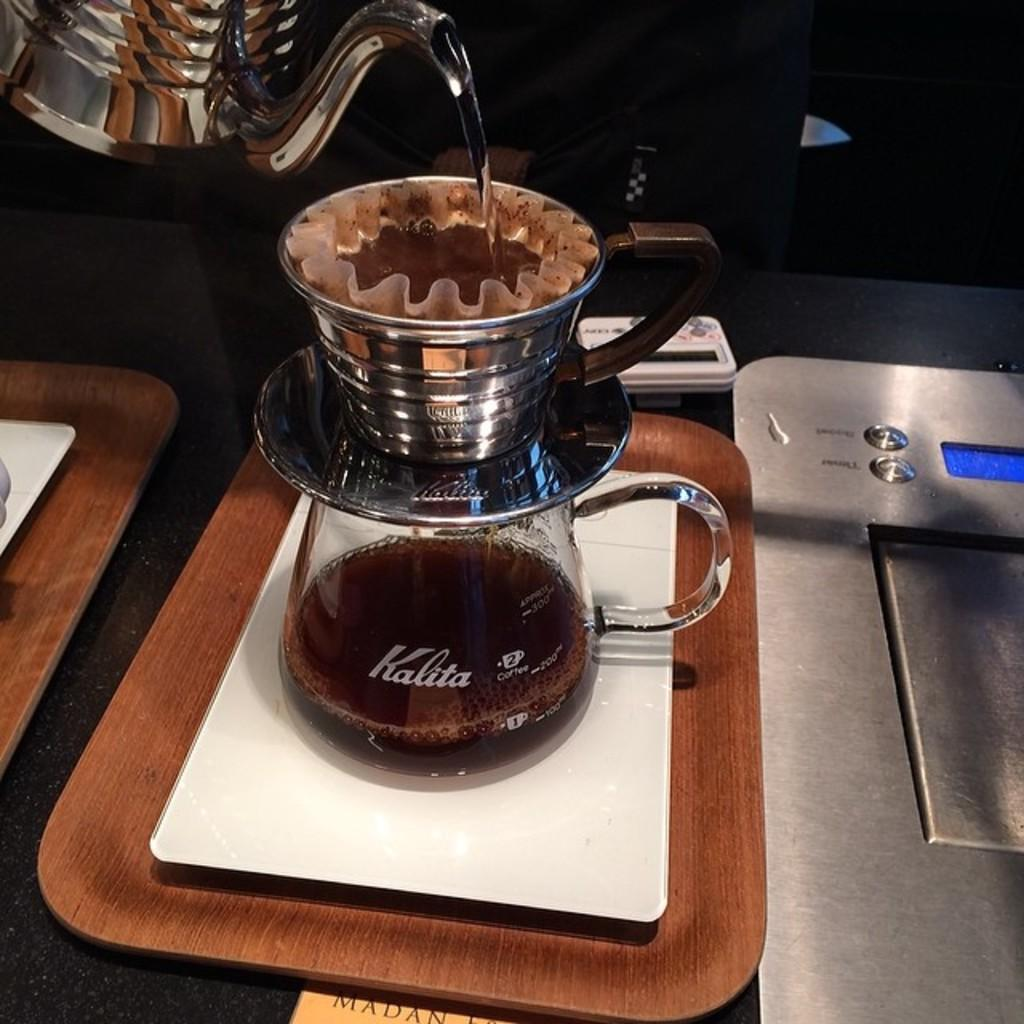<image>
Render a clear and concise summary of the photo. a glass of coffe with Kalita on the glass 